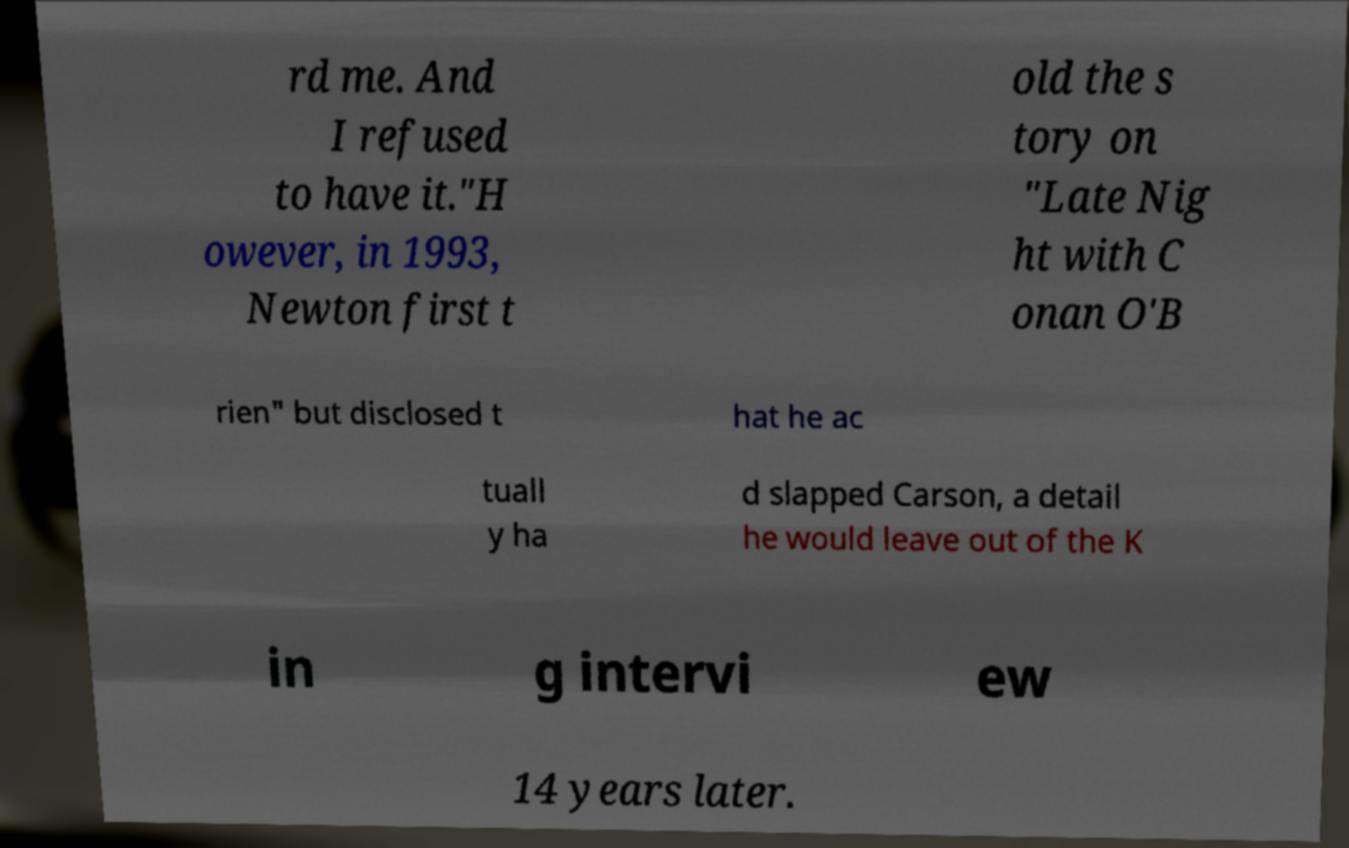I need the written content from this picture converted into text. Can you do that? rd me. And I refused to have it."H owever, in 1993, Newton first t old the s tory on "Late Nig ht with C onan O'B rien" but disclosed t hat he ac tuall y ha d slapped Carson, a detail he would leave out of the K in g intervi ew 14 years later. 